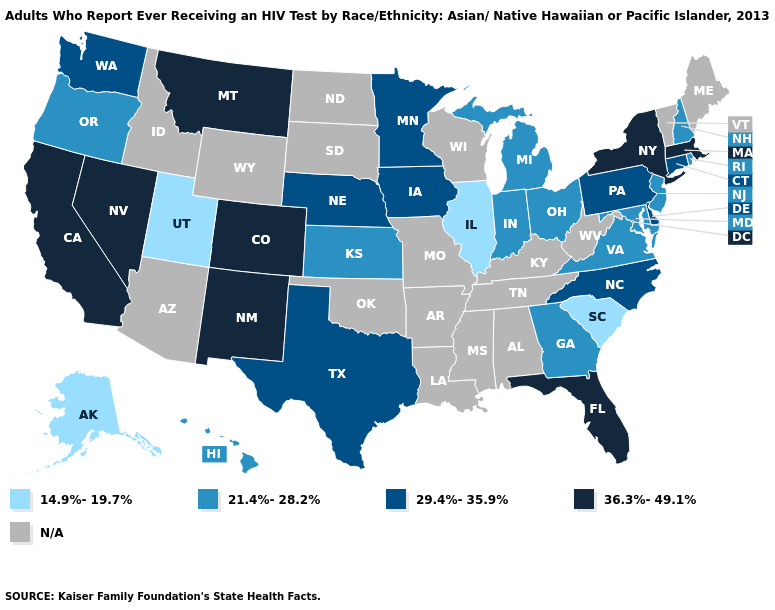Does Utah have the lowest value in the USA?
Concise answer only. Yes. Does the first symbol in the legend represent the smallest category?
Quick response, please. Yes. Name the states that have a value in the range N/A?
Write a very short answer. Alabama, Arizona, Arkansas, Idaho, Kentucky, Louisiana, Maine, Mississippi, Missouri, North Dakota, Oklahoma, South Dakota, Tennessee, Vermont, West Virginia, Wisconsin, Wyoming. Does Montana have the highest value in the USA?
Quick response, please. Yes. Name the states that have a value in the range N/A?
Write a very short answer. Alabama, Arizona, Arkansas, Idaho, Kentucky, Louisiana, Maine, Mississippi, Missouri, North Dakota, Oklahoma, South Dakota, Tennessee, Vermont, West Virginia, Wisconsin, Wyoming. What is the lowest value in the USA?
Answer briefly. 14.9%-19.7%. Does Colorado have the highest value in the West?
Give a very brief answer. Yes. Which states hav the highest value in the Northeast?
Short answer required. Massachusetts, New York. Among the states that border Indiana , which have the highest value?
Keep it brief. Michigan, Ohio. Does the map have missing data?
Write a very short answer. Yes. Name the states that have a value in the range 29.4%-35.9%?
Answer briefly. Connecticut, Delaware, Iowa, Minnesota, Nebraska, North Carolina, Pennsylvania, Texas, Washington. Which states have the lowest value in the USA?
Concise answer only. Alaska, Illinois, South Carolina, Utah. Which states hav the highest value in the Northeast?
Quick response, please. Massachusetts, New York. 